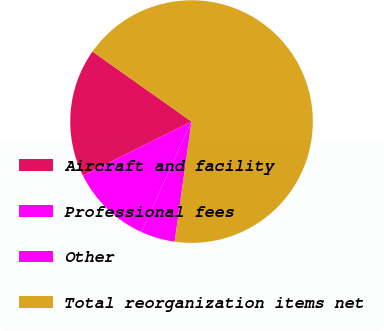<chart> <loc_0><loc_0><loc_500><loc_500><pie_chart><fcel>Aircraft and facility<fcel>Professional fees<fcel>Other<fcel>Total reorganization items net<nl><fcel>17.14%<fcel>10.86%<fcel>4.57%<fcel>67.43%<nl></chart> 